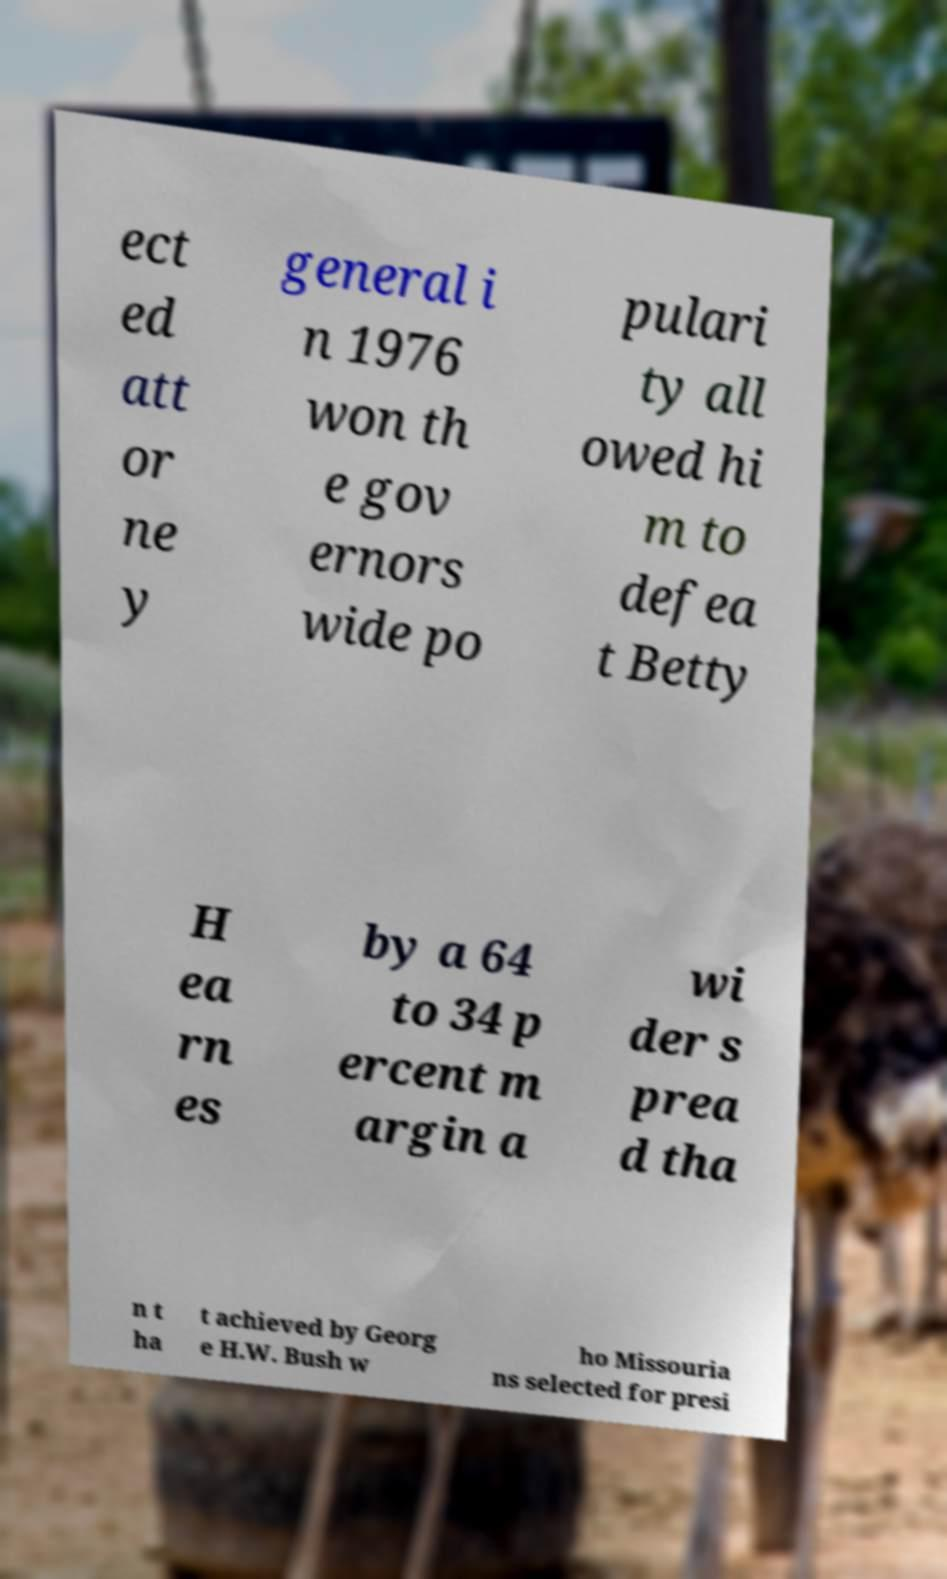I need the written content from this picture converted into text. Can you do that? ect ed att or ne y general i n 1976 won th e gov ernors wide po pulari ty all owed hi m to defea t Betty H ea rn es by a 64 to 34 p ercent m argin a wi der s prea d tha n t ha t achieved by Georg e H.W. Bush w ho Missouria ns selected for presi 